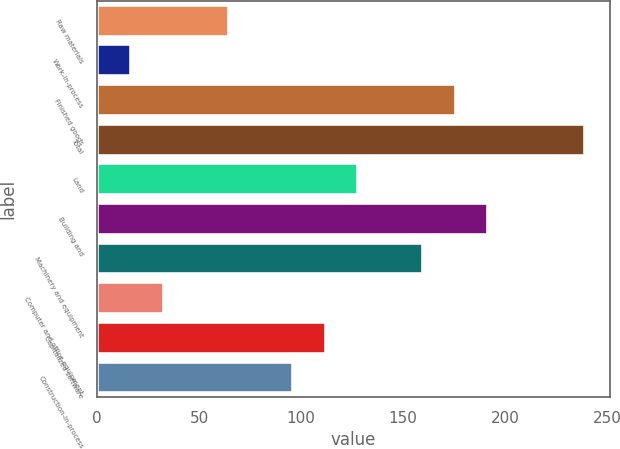Convert chart to OTSL. <chart><loc_0><loc_0><loc_500><loc_500><bar_chart><fcel>Raw materials<fcel>Work-in-process<fcel>Finished goods<fcel>Total<fcel>Land<fcel>Building and<fcel>Machinery and equipment<fcel>Computer and office equipment<fcel>Capitalized software<fcel>Construction-in-process<nl><fcel>64.4<fcel>16.7<fcel>175.7<fcel>239.3<fcel>128<fcel>191.6<fcel>159.8<fcel>32.6<fcel>112.1<fcel>96.2<nl></chart> 